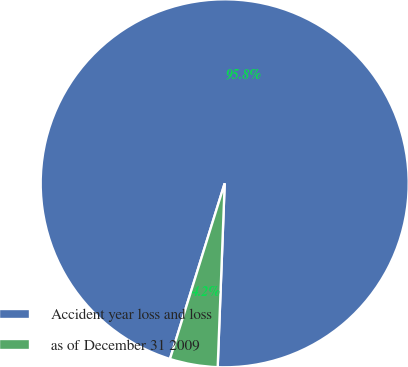Convert chart to OTSL. <chart><loc_0><loc_0><loc_500><loc_500><pie_chart><fcel>Accident year loss and loss<fcel>as of December 31 2009<nl><fcel>95.8%<fcel>4.2%<nl></chart> 